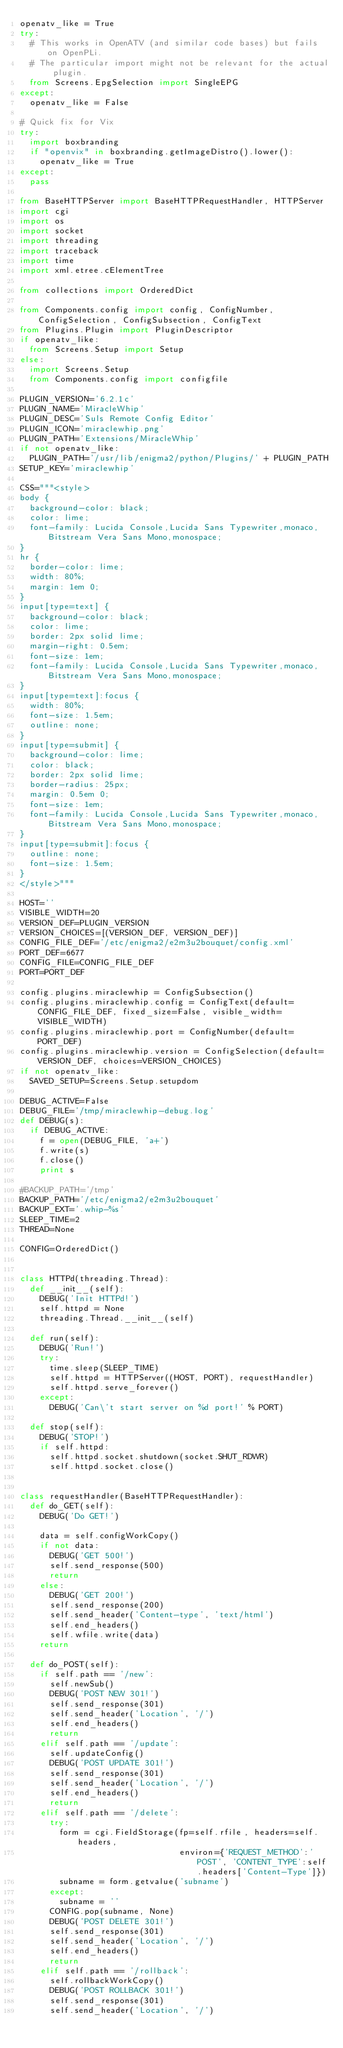<code> <loc_0><loc_0><loc_500><loc_500><_Python_>openatv_like = True
try:
  # This works in OpenATV (and similar code bases) but fails on OpenPLi.
  # The particular import might not be relevant for the actual plugin.
  from Screens.EpgSelection import SingleEPG
except:
  openatv_like = False

# Quick fix for Vix
try:
  import boxbranding
  if "openvix" in boxbranding.getImageDistro().lower():
    openatv_like = True
except:
  pass

from BaseHTTPServer import BaseHTTPRequestHandler, HTTPServer
import cgi
import os
import socket
import threading
import traceback
import time
import xml.etree.cElementTree

from collections import OrderedDict

from Components.config import config, ConfigNumber, ConfigSelection, ConfigSubsection, ConfigText
from Plugins.Plugin import PluginDescriptor
if openatv_like:
  from Screens.Setup import Setup
else:
  import Screens.Setup
  from Components.config import configfile

PLUGIN_VERSION='6.2.1c'
PLUGIN_NAME='MiracleWhip'
PLUGIN_DESC='Suls Remote Config Editor'
PLUGIN_ICON='miraclewhip.png'
PLUGIN_PATH='Extensions/MiracleWhip'
if not openatv_like:
  PLUGIN_PATH='/usr/lib/enigma2/python/Plugins/' + PLUGIN_PATH
SETUP_KEY='miraclewhip'

CSS="""<style>
body {
  background-color: black;
  color: lime; 
  font-family: Lucida Console,Lucida Sans Typewriter,monaco,Bitstream Vera Sans Mono,monospace;
}
hr {
  border-color: lime;
  width: 80%; 
  margin: 1em 0;
}
input[type=text] {
  background-color: black;
  color: lime;
  border: 2px solid lime;
  margin-right: 0.5em;
  font-size: 1em;
  font-family: Lucida Console,Lucida Sans Typewriter,monaco,Bitstream Vera Sans Mono,monospace;
}
input[type=text]:focus {
  width: 80%;
  font-size: 1.5em;
  outline: none;
}
input[type=submit] {
  background-color: lime;
  color: black;
  border: 2px solid lime;
  border-radius: 25px;
  margin: 0.5em 0;
  font-size: 1em;
  font-family: Lucida Console,Lucida Sans Typewriter,monaco,Bitstream Vera Sans Mono,monospace;
}
input[type=submit]:focus {
  outline: none;
  font-size: 1.5em;
}
</style>"""

HOST=''
VISIBLE_WIDTH=20
VERSION_DEF=PLUGIN_VERSION
VERSION_CHOICES=[(VERSION_DEF, VERSION_DEF)]
CONFIG_FILE_DEF='/etc/enigma2/e2m3u2bouquet/config.xml'
PORT_DEF=6677
CONFIG_FILE=CONFIG_FILE_DEF
PORT=PORT_DEF

config.plugins.miraclewhip = ConfigSubsection()
config.plugins.miraclewhip.config = ConfigText(default=CONFIG_FILE_DEF, fixed_size=False, visible_width=VISIBLE_WIDTH)
config.plugins.miraclewhip.port = ConfigNumber(default=PORT_DEF)
config.plugins.miraclewhip.version = ConfigSelection(default=VERSION_DEF, choices=VERSION_CHOICES)
if not openatv_like:
  SAVED_SETUP=Screens.Setup.setupdom

DEBUG_ACTIVE=False
DEBUG_FILE='/tmp/miraclewhip-debug.log'
def DEBUG(s):
  if DEBUG_ACTIVE:
    f = open(DEBUG_FILE, 'a+')
    f.write(s)
    f.close()
    print s

#BACKUP_PATH='/tmp'
BACKUP_PATH='/etc/enigma2/e2m3u2bouquet'
BACKUP_EXT='.whip-%s'
SLEEP_TIME=2
THREAD=None

CONFIG=OrderedDict()


class HTTPd(threading.Thread):
  def __init__(self):
    DEBUG('Init HTTPd!')
    self.httpd = None
    threading.Thread.__init__(self)

  def run(self):
    DEBUG('Run!')
    try:
      time.sleep(SLEEP_TIME)
      self.httpd = HTTPServer((HOST, PORT), requestHandler)
      self.httpd.serve_forever()
    except:
      DEBUG('Can\'t start server on %d port!' % PORT)

  def stop(self):
    DEBUG('STOP!')
    if self.httpd:
      self.httpd.socket.shutdown(socket.SHUT_RDWR)
      self.httpd.socket.close()


class requestHandler(BaseHTTPRequestHandler):
  def do_GET(self):
    DEBUG('Do GET!')
    
    data = self.configWorkCopy()
    if not data:
      DEBUG('GET 500!')
      self.send_response(500)
      return
    else:
      DEBUG('GET 200!')
      self.send_response(200)
      self.send_header('Content-type', 'text/html')
      self.end_headers()
      self.wfile.write(data)
    return

  def do_POST(self):
    if self.path == '/new':
      self.newSub()
      DEBUG('POST NEW 301!')
      self.send_response(301)
      self.send_header('Location', '/')
      self.end_headers()
      return
    elif self.path == '/update':
      self.updateConfig()
      DEBUG('POST UPDATE 301!')
      self.send_response(301)
      self.send_header('Location', '/')
      self.end_headers()
      return
    elif self.path == '/delete':
      try:
        form = cgi.FieldStorage(fp=self.rfile, headers=self.headers,
                                environ={'REQUEST_METHOD':'POST', 'CONTENT_TYPE':self.headers['Content-Type']})
        subname = form.getvalue('subname')
      except:
        subname = ''
      CONFIG.pop(subname, None)
      DEBUG('POST DELETE 301!')
      self.send_response(301)
      self.send_header('Location', '/')
      self.end_headers()
      return
    elif self.path == '/rollback':
      self.rollbackWorkCopy()
      DEBUG('POST ROLLBACK 301!')
      self.send_response(301)
      self.send_header('Location', '/')</code> 